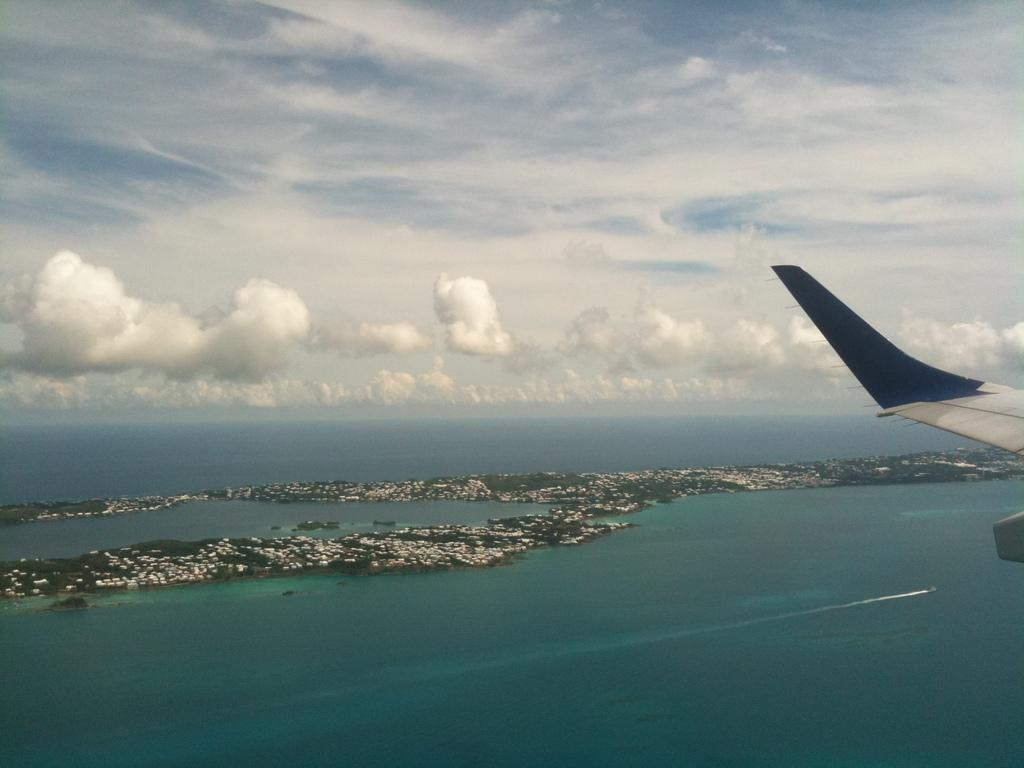What is the main subject of the image? The main subject of the image is an airplane tail. What can be seen in the foreground of the image? There is water visible in the image. What else is present in the image besides the airplane tail and water? There are some objects in the image. What is visible in the background of the image? The sky is visible in the background of the image. What can be observed about the sky in the image? Clouds are present in the sky. What type of sheet is being used to control the airplane in the image? There is no sheet or control of an airplane visible in the image; it only shows an airplane tail and water. 